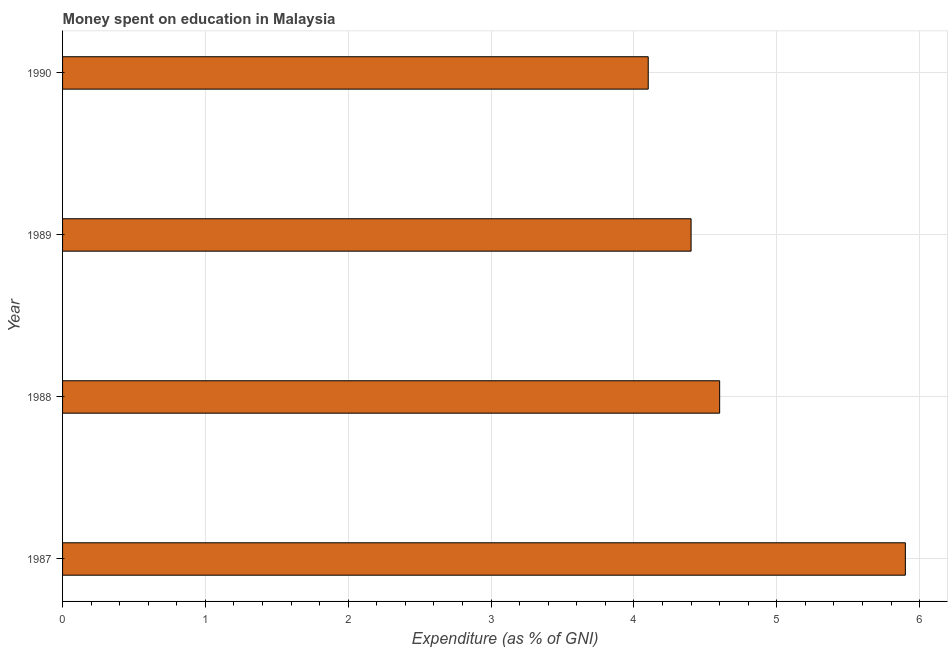What is the title of the graph?
Keep it short and to the point. Money spent on education in Malaysia. What is the label or title of the X-axis?
Your response must be concise. Expenditure (as % of GNI). What is the label or title of the Y-axis?
Give a very brief answer. Year. What is the expenditure on education in 1987?
Give a very brief answer. 5.9. Across all years, what is the maximum expenditure on education?
Ensure brevity in your answer.  5.9. Across all years, what is the minimum expenditure on education?
Ensure brevity in your answer.  4.1. What is the average expenditure on education per year?
Make the answer very short. 4.75. What is the median expenditure on education?
Offer a very short reply. 4.5. Do a majority of the years between 1987 and 1988 (inclusive) have expenditure on education greater than 3.4 %?
Offer a terse response. Yes. What is the ratio of the expenditure on education in 1987 to that in 1989?
Provide a succinct answer. 1.34. What is the difference between the highest and the second highest expenditure on education?
Provide a succinct answer. 1.3. Is the sum of the expenditure on education in 1987 and 1989 greater than the maximum expenditure on education across all years?
Provide a short and direct response. Yes. What is the difference between the highest and the lowest expenditure on education?
Ensure brevity in your answer.  1.8. In how many years, is the expenditure on education greater than the average expenditure on education taken over all years?
Your answer should be compact. 1. What is the difference between two consecutive major ticks on the X-axis?
Make the answer very short. 1. What is the Expenditure (as % of GNI) in 1990?
Make the answer very short. 4.1. What is the difference between the Expenditure (as % of GNI) in 1987 and 1988?
Provide a short and direct response. 1.3. What is the difference between the Expenditure (as % of GNI) in 1987 and 1990?
Keep it short and to the point. 1.8. What is the difference between the Expenditure (as % of GNI) in 1988 and 1989?
Offer a very short reply. 0.2. What is the ratio of the Expenditure (as % of GNI) in 1987 to that in 1988?
Your answer should be compact. 1.28. What is the ratio of the Expenditure (as % of GNI) in 1987 to that in 1989?
Your response must be concise. 1.34. What is the ratio of the Expenditure (as % of GNI) in 1987 to that in 1990?
Offer a very short reply. 1.44. What is the ratio of the Expenditure (as % of GNI) in 1988 to that in 1989?
Keep it short and to the point. 1.04. What is the ratio of the Expenditure (as % of GNI) in 1988 to that in 1990?
Make the answer very short. 1.12. What is the ratio of the Expenditure (as % of GNI) in 1989 to that in 1990?
Offer a terse response. 1.07. 